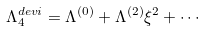<formula> <loc_0><loc_0><loc_500><loc_500>\Lambda _ { 4 } ^ { d e v i } = \Lambda ^ { ( 0 ) } + \Lambda ^ { ( 2 ) } \xi ^ { 2 } + \cdots</formula> 